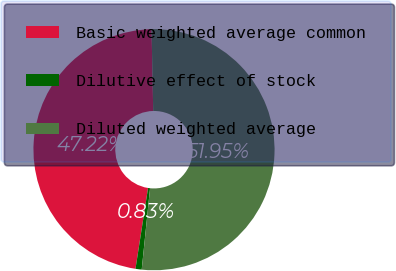Convert chart. <chart><loc_0><loc_0><loc_500><loc_500><pie_chart><fcel>Basic weighted average common<fcel>Dilutive effect of stock<fcel>Diluted weighted average<nl><fcel>47.22%<fcel>0.83%<fcel>51.95%<nl></chart> 